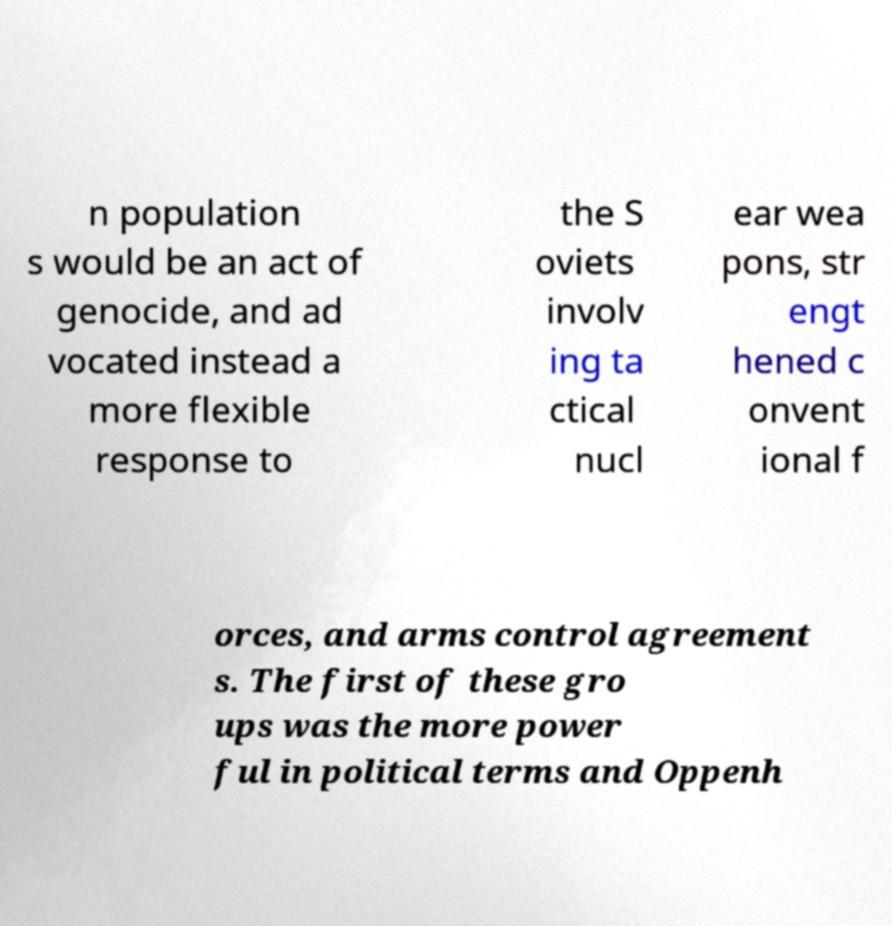For documentation purposes, I need the text within this image transcribed. Could you provide that? n population s would be an act of genocide, and ad vocated instead a more flexible response to the S oviets involv ing ta ctical nucl ear wea pons, str engt hened c onvent ional f orces, and arms control agreement s. The first of these gro ups was the more power ful in political terms and Oppenh 